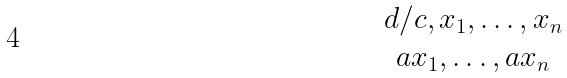<formula> <loc_0><loc_0><loc_500><loc_500>\begin{matrix} { d / c , x _ { 1 } , \dots , x _ { n } } \\ { a x _ { 1 } , \dots , a x _ { n } } \end{matrix}</formula> 